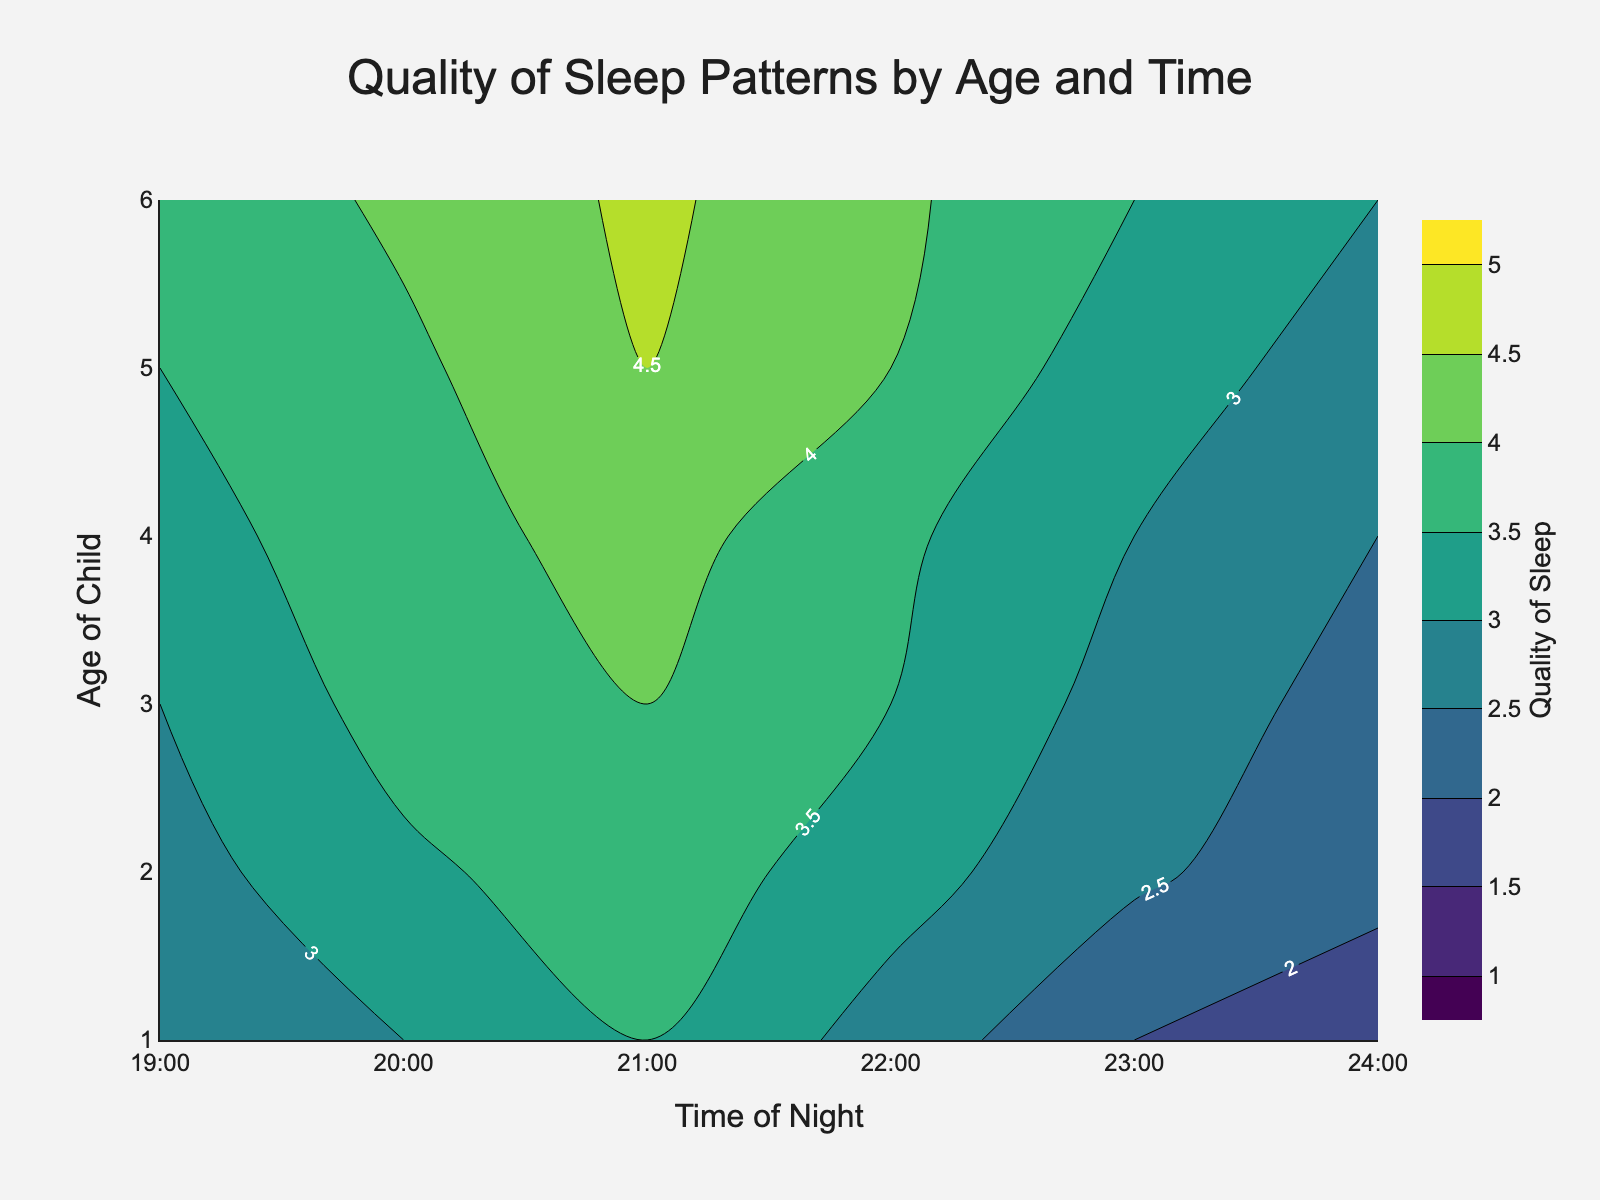What is the title of the plot? The title of the plot is usually prominently displayed at the top of the figure. Observing the top section, we can see it reads "Quality of Sleep Patterns by Age and Time."
Answer: Quality of Sleep Patterns by Age and Time What does the color gradient represent in this plot? The color gradient in a contour plot typically represents the intensity or magnitude of the variable being studied. The color bar on the right indicates that different shades represent varying levels of "Quality of Sleep," ranging from 1 to 5.
Answer: Quality of Sleep At what age and time is the peak quality of sleep observed? By examining the plot, we need to find the darkest (or most intense) contour region which indicates the highest value on the color scale. This peak is around age 6 at 21:00.
Answer: Age 6 at 21:00 Which age group has the least quality of sleep at midnight? By looking at the 24:00 time column, we can identify the lightest color contours, which signify the lowest quality of sleep. The lightest color in the midnight column appears at age 1.
Answer: Age 1 What time of the night generally shows the highest quality of sleep across different ages? By scanning horizontally across different ages and observing the color intensities, the darkest shades (indicating higher quality of sleep) are consistently around 21:00.
Answer: 21:00 How does the quality of sleep change between 19:00 and 24:00 for children aged 4? We trace the quality of sleep figures for age 4 along the time axis from 19:00 to 24:00, observing a peak around 21:00 (4.2) and then a gradual decrease towards midnight (2.5).
Answer: Peaks at 21:00 and decreases towards midnight Which age group shows the greatest variation in sleep quality across the night? This involves examining the breadth of change in color intensity for each age group. Age 6 shows high variations, peaking at 21:00 (4.6) and declining to (3.0) by 24:00.
Answer: Age 6 What is the quality of sleep for a 3-year-old at 20:00? Locate the contour label or refer to the color gradation at the intersection of age 3 and time 20:00. The value here is 3.7.
Answer: 3.7 Between ages 2 and 5, which age group maintains the highest average quality of sleep? Calculate the average quality scores for each age group from 19:00 to 24:00 and identify the highest. For children aged 5, the averages are (3.5 + 3.9 + 4.5 + 4.0 + 3.2 + 2.8) / 6 = 3.65, which is higher than other groups between ages 2 and 5.
Answer: Age 5 What general trend can you observe about the quality of sleep as the night progresses? Reviewing the overall pattern, there is a common trend that quality of sleep tends to be higher around early night hours (around 21:00) and gradually decreases towards 24:00.
Answer: Peaks around 21:00 and decreases towards 24:00 